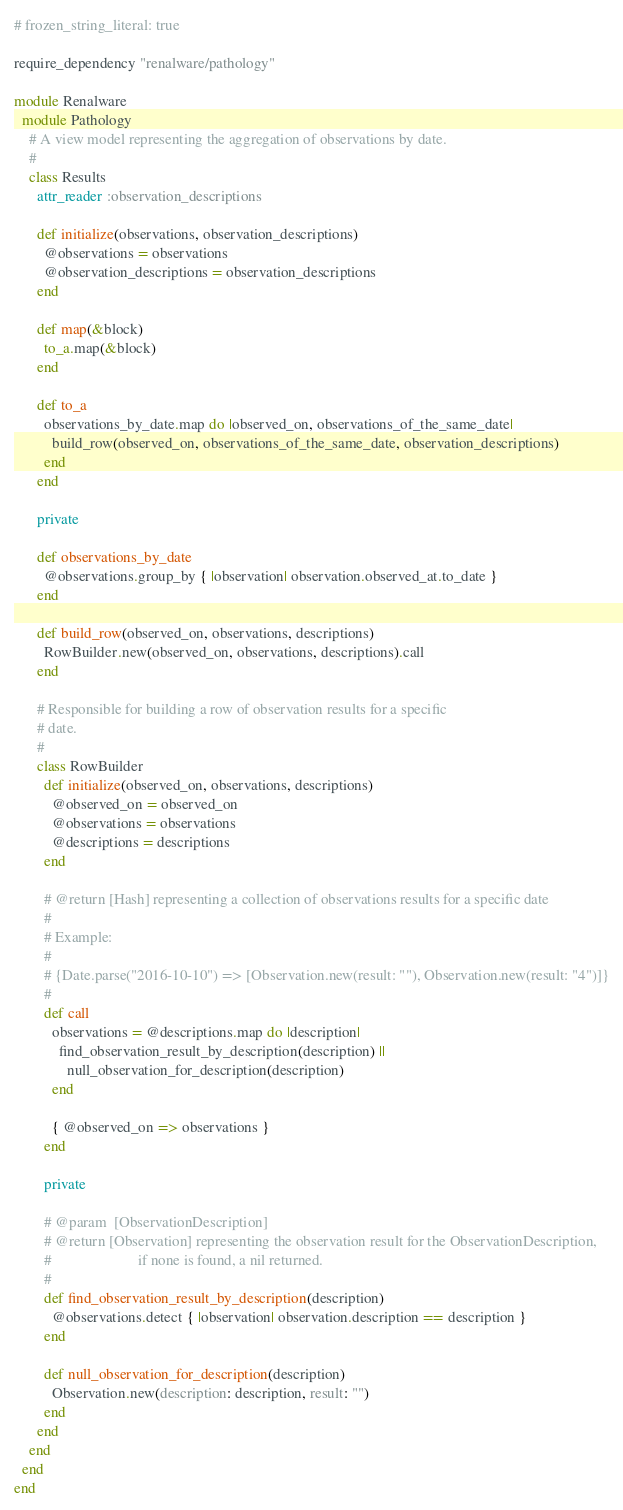Convert code to text. <code><loc_0><loc_0><loc_500><loc_500><_Ruby_># frozen_string_literal: true

require_dependency "renalware/pathology"

module Renalware
  module Pathology
    # A view model representing the aggregation of observations by date.
    #
    class Results
      attr_reader :observation_descriptions

      def initialize(observations, observation_descriptions)
        @observations = observations
        @observation_descriptions = observation_descriptions
      end

      def map(&block)
        to_a.map(&block)
      end

      def to_a
        observations_by_date.map do |observed_on, observations_of_the_same_date|
          build_row(observed_on, observations_of_the_same_date, observation_descriptions)
        end
      end

      private

      def observations_by_date
        @observations.group_by { |observation| observation.observed_at.to_date }
      end

      def build_row(observed_on, observations, descriptions)
        RowBuilder.new(observed_on, observations, descriptions).call
      end

      # Responsible for building a row of observation results for a specific
      # date.
      #
      class RowBuilder
        def initialize(observed_on, observations, descriptions)
          @observed_on = observed_on
          @observations = observations
          @descriptions = descriptions
        end

        # @return [Hash] representing a collection of observations results for a specific date
        #
        # Example:
        #
        # {Date.parse("2016-10-10") => [Observation.new(result: ""), Observation.new(result: "4")]}
        #
        def call
          observations = @descriptions.map do |description|
            find_observation_result_by_description(description) ||
              null_observation_for_description(description)
          end

          { @observed_on => observations }
        end

        private

        # @param  [ObservationDescription]
        # @return [Observation] representing the observation result for the ObservationDescription,
        #                       if none is found, a nil returned.
        #
        def find_observation_result_by_description(description)
          @observations.detect { |observation| observation.description == description }
        end

        def null_observation_for_description(description)
          Observation.new(description: description, result: "")
        end
      end
    end
  end
end
</code> 